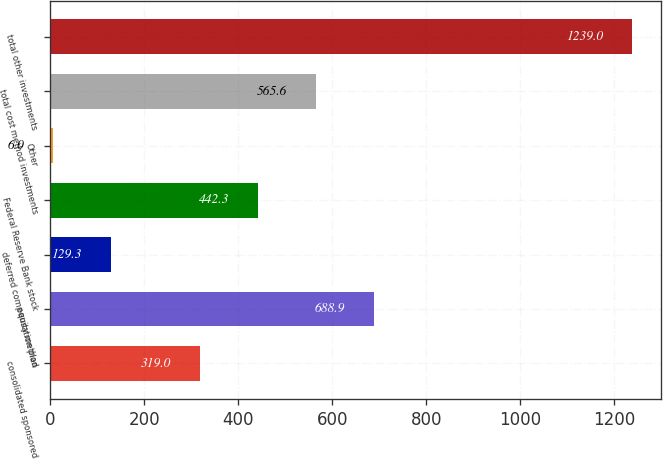Convert chart. <chart><loc_0><loc_0><loc_500><loc_500><bar_chart><fcel>consolidated sponsored<fcel>equity method<fcel>deferred compensation plan<fcel>Federal Reserve Bank stock<fcel>Other<fcel>total cost method investments<fcel>total other investments<nl><fcel>319<fcel>688.9<fcel>129.3<fcel>442.3<fcel>6<fcel>565.6<fcel>1239<nl></chart> 